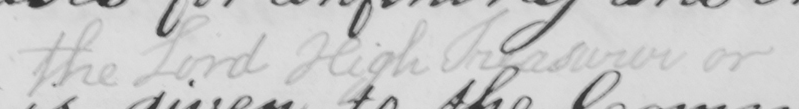What does this handwritten line say? the Lord High Treasurer or 